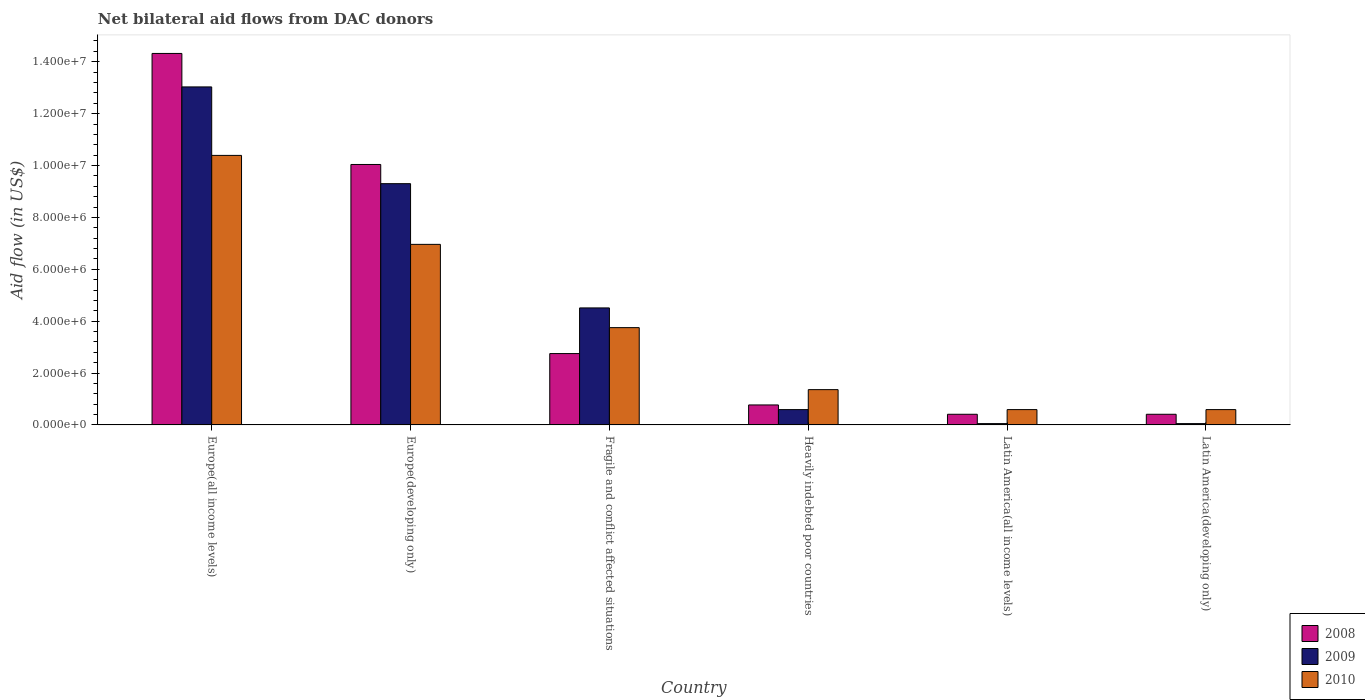How many different coloured bars are there?
Your answer should be compact. 3. How many groups of bars are there?
Give a very brief answer. 6. How many bars are there on the 2nd tick from the left?
Offer a very short reply. 3. How many bars are there on the 2nd tick from the right?
Offer a very short reply. 3. What is the label of the 1st group of bars from the left?
Provide a short and direct response. Europe(all income levels). In how many cases, is the number of bars for a given country not equal to the number of legend labels?
Provide a short and direct response. 0. What is the net bilateral aid flow in 2009 in Europe(all income levels)?
Offer a terse response. 1.30e+07. Across all countries, what is the maximum net bilateral aid flow in 2010?
Provide a short and direct response. 1.04e+07. In which country was the net bilateral aid flow in 2008 maximum?
Offer a very short reply. Europe(all income levels). In which country was the net bilateral aid flow in 2009 minimum?
Your answer should be compact. Latin America(all income levels). What is the total net bilateral aid flow in 2008 in the graph?
Offer a terse response. 2.87e+07. What is the difference between the net bilateral aid flow in 2010 in Heavily indebted poor countries and that in Latin America(all income levels)?
Your answer should be very brief. 7.70e+05. What is the difference between the net bilateral aid flow in 2010 in Latin America(all income levels) and the net bilateral aid flow in 2008 in Fragile and conflict affected situations?
Provide a short and direct response. -2.16e+06. What is the average net bilateral aid flow in 2009 per country?
Your answer should be very brief. 4.59e+06. What is the difference between the net bilateral aid flow of/in 2010 and net bilateral aid flow of/in 2009 in Europe(developing only)?
Offer a very short reply. -2.34e+06. What is the ratio of the net bilateral aid flow in 2008 in Europe(all income levels) to that in Europe(developing only)?
Provide a succinct answer. 1.43. Is the difference between the net bilateral aid flow in 2010 in Fragile and conflict affected situations and Latin America(all income levels) greater than the difference between the net bilateral aid flow in 2009 in Fragile and conflict affected situations and Latin America(all income levels)?
Give a very brief answer. No. What is the difference between the highest and the second highest net bilateral aid flow in 2009?
Keep it short and to the point. 3.73e+06. What is the difference between the highest and the lowest net bilateral aid flow in 2010?
Keep it short and to the point. 9.80e+06. In how many countries, is the net bilateral aid flow in 2008 greater than the average net bilateral aid flow in 2008 taken over all countries?
Give a very brief answer. 2. Is the sum of the net bilateral aid flow in 2008 in Europe(all income levels) and Latin America(all income levels) greater than the maximum net bilateral aid flow in 2009 across all countries?
Give a very brief answer. Yes. How many bars are there?
Provide a succinct answer. 18. How many countries are there in the graph?
Your answer should be very brief. 6. What is the difference between two consecutive major ticks on the Y-axis?
Offer a very short reply. 2.00e+06. Does the graph contain grids?
Offer a very short reply. No. How many legend labels are there?
Provide a short and direct response. 3. What is the title of the graph?
Give a very brief answer. Net bilateral aid flows from DAC donors. Does "2009" appear as one of the legend labels in the graph?
Give a very brief answer. Yes. What is the label or title of the Y-axis?
Offer a very short reply. Aid flow (in US$). What is the Aid flow (in US$) in 2008 in Europe(all income levels)?
Offer a very short reply. 1.43e+07. What is the Aid flow (in US$) of 2009 in Europe(all income levels)?
Keep it short and to the point. 1.30e+07. What is the Aid flow (in US$) of 2010 in Europe(all income levels)?
Offer a very short reply. 1.04e+07. What is the Aid flow (in US$) of 2008 in Europe(developing only)?
Ensure brevity in your answer.  1.00e+07. What is the Aid flow (in US$) in 2009 in Europe(developing only)?
Provide a short and direct response. 9.30e+06. What is the Aid flow (in US$) in 2010 in Europe(developing only)?
Provide a succinct answer. 6.96e+06. What is the Aid flow (in US$) of 2008 in Fragile and conflict affected situations?
Ensure brevity in your answer.  2.75e+06. What is the Aid flow (in US$) in 2009 in Fragile and conflict affected situations?
Your answer should be compact. 4.51e+06. What is the Aid flow (in US$) in 2010 in Fragile and conflict affected situations?
Your answer should be compact. 3.75e+06. What is the Aid flow (in US$) of 2008 in Heavily indebted poor countries?
Keep it short and to the point. 7.70e+05. What is the Aid flow (in US$) in 2009 in Heavily indebted poor countries?
Ensure brevity in your answer.  5.90e+05. What is the Aid flow (in US$) in 2010 in Heavily indebted poor countries?
Ensure brevity in your answer.  1.36e+06. What is the Aid flow (in US$) of 2010 in Latin America(all income levels)?
Ensure brevity in your answer.  5.90e+05. What is the Aid flow (in US$) of 2008 in Latin America(developing only)?
Ensure brevity in your answer.  4.10e+05. What is the Aid flow (in US$) in 2009 in Latin America(developing only)?
Provide a succinct answer. 5.00e+04. What is the Aid flow (in US$) in 2010 in Latin America(developing only)?
Provide a short and direct response. 5.90e+05. Across all countries, what is the maximum Aid flow (in US$) of 2008?
Your answer should be compact. 1.43e+07. Across all countries, what is the maximum Aid flow (in US$) of 2009?
Your answer should be compact. 1.30e+07. Across all countries, what is the maximum Aid flow (in US$) in 2010?
Provide a succinct answer. 1.04e+07. Across all countries, what is the minimum Aid flow (in US$) of 2008?
Your answer should be compact. 4.10e+05. Across all countries, what is the minimum Aid flow (in US$) in 2010?
Provide a succinct answer. 5.90e+05. What is the total Aid flow (in US$) in 2008 in the graph?
Offer a very short reply. 2.87e+07. What is the total Aid flow (in US$) of 2009 in the graph?
Provide a short and direct response. 2.75e+07. What is the total Aid flow (in US$) in 2010 in the graph?
Give a very brief answer. 2.36e+07. What is the difference between the Aid flow (in US$) in 2008 in Europe(all income levels) and that in Europe(developing only)?
Provide a succinct answer. 4.28e+06. What is the difference between the Aid flow (in US$) of 2009 in Europe(all income levels) and that in Europe(developing only)?
Your answer should be very brief. 3.73e+06. What is the difference between the Aid flow (in US$) of 2010 in Europe(all income levels) and that in Europe(developing only)?
Provide a short and direct response. 3.43e+06. What is the difference between the Aid flow (in US$) of 2008 in Europe(all income levels) and that in Fragile and conflict affected situations?
Your response must be concise. 1.16e+07. What is the difference between the Aid flow (in US$) in 2009 in Europe(all income levels) and that in Fragile and conflict affected situations?
Provide a succinct answer. 8.52e+06. What is the difference between the Aid flow (in US$) in 2010 in Europe(all income levels) and that in Fragile and conflict affected situations?
Give a very brief answer. 6.64e+06. What is the difference between the Aid flow (in US$) of 2008 in Europe(all income levels) and that in Heavily indebted poor countries?
Make the answer very short. 1.36e+07. What is the difference between the Aid flow (in US$) in 2009 in Europe(all income levels) and that in Heavily indebted poor countries?
Make the answer very short. 1.24e+07. What is the difference between the Aid flow (in US$) in 2010 in Europe(all income levels) and that in Heavily indebted poor countries?
Keep it short and to the point. 9.03e+06. What is the difference between the Aid flow (in US$) in 2008 in Europe(all income levels) and that in Latin America(all income levels)?
Your answer should be very brief. 1.39e+07. What is the difference between the Aid flow (in US$) of 2009 in Europe(all income levels) and that in Latin America(all income levels)?
Make the answer very short. 1.30e+07. What is the difference between the Aid flow (in US$) in 2010 in Europe(all income levels) and that in Latin America(all income levels)?
Your answer should be compact. 9.80e+06. What is the difference between the Aid flow (in US$) of 2008 in Europe(all income levels) and that in Latin America(developing only)?
Provide a short and direct response. 1.39e+07. What is the difference between the Aid flow (in US$) in 2009 in Europe(all income levels) and that in Latin America(developing only)?
Ensure brevity in your answer.  1.30e+07. What is the difference between the Aid flow (in US$) of 2010 in Europe(all income levels) and that in Latin America(developing only)?
Provide a succinct answer. 9.80e+06. What is the difference between the Aid flow (in US$) in 2008 in Europe(developing only) and that in Fragile and conflict affected situations?
Your response must be concise. 7.29e+06. What is the difference between the Aid flow (in US$) in 2009 in Europe(developing only) and that in Fragile and conflict affected situations?
Offer a very short reply. 4.79e+06. What is the difference between the Aid flow (in US$) in 2010 in Europe(developing only) and that in Fragile and conflict affected situations?
Offer a very short reply. 3.21e+06. What is the difference between the Aid flow (in US$) of 2008 in Europe(developing only) and that in Heavily indebted poor countries?
Ensure brevity in your answer.  9.27e+06. What is the difference between the Aid flow (in US$) in 2009 in Europe(developing only) and that in Heavily indebted poor countries?
Keep it short and to the point. 8.71e+06. What is the difference between the Aid flow (in US$) in 2010 in Europe(developing only) and that in Heavily indebted poor countries?
Give a very brief answer. 5.60e+06. What is the difference between the Aid flow (in US$) of 2008 in Europe(developing only) and that in Latin America(all income levels)?
Give a very brief answer. 9.63e+06. What is the difference between the Aid flow (in US$) in 2009 in Europe(developing only) and that in Latin America(all income levels)?
Your answer should be very brief. 9.25e+06. What is the difference between the Aid flow (in US$) of 2010 in Europe(developing only) and that in Latin America(all income levels)?
Give a very brief answer. 6.37e+06. What is the difference between the Aid flow (in US$) of 2008 in Europe(developing only) and that in Latin America(developing only)?
Your answer should be compact. 9.63e+06. What is the difference between the Aid flow (in US$) in 2009 in Europe(developing only) and that in Latin America(developing only)?
Make the answer very short. 9.25e+06. What is the difference between the Aid flow (in US$) in 2010 in Europe(developing only) and that in Latin America(developing only)?
Ensure brevity in your answer.  6.37e+06. What is the difference between the Aid flow (in US$) of 2008 in Fragile and conflict affected situations and that in Heavily indebted poor countries?
Your answer should be compact. 1.98e+06. What is the difference between the Aid flow (in US$) in 2009 in Fragile and conflict affected situations and that in Heavily indebted poor countries?
Provide a succinct answer. 3.92e+06. What is the difference between the Aid flow (in US$) in 2010 in Fragile and conflict affected situations and that in Heavily indebted poor countries?
Offer a terse response. 2.39e+06. What is the difference between the Aid flow (in US$) of 2008 in Fragile and conflict affected situations and that in Latin America(all income levels)?
Offer a very short reply. 2.34e+06. What is the difference between the Aid flow (in US$) of 2009 in Fragile and conflict affected situations and that in Latin America(all income levels)?
Give a very brief answer. 4.46e+06. What is the difference between the Aid flow (in US$) of 2010 in Fragile and conflict affected situations and that in Latin America(all income levels)?
Your answer should be compact. 3.16e+06. What is the difference between the Aid flow (in US$) of 2008 in Fragile and conflict affected situations and that in Latin America(developing only)?
Offer a very short reply. 2.34e+06. What is the difference between the Aid flow (in US$) in 2009 in Fragile and conflict affected situations and that in Latin America(developing only)?
Keep it short and to the point. 4.46e+06. What is the difference between the Aid flow (in US$) of 2010 in Fragile and conflict affected situations and that in Latin America(developing only)?
Your answer should be very brief. 3.16e+06. What is the difference between the Aid flow (in US$) in 2009 in Heavily indebted poor countries and that in Latin America(all income levels)?
Your response must be concise. 5.40e+05. What is the difference between the Aid flow (in US$) in 2010 in Heavily indebted poor countries and that in Latin America(all income levels)?
Provide a short and direct response. 7.70e+05. What is the difference between the Aid flow (in US$) of 2008 in Heavily indebted poor countries and that in Latin America(developing only)?
Offer a very short reply. 3.60e+05. What is the difference between the Aid flow (in US$) in 2009 in Heavily indebted poor countries and that in Latin America(developing only)?
Your response must be concise. 5.40e+05. What is the difference between the Aid flow (in US$) in 2010 in Heavily indebted poor countries and that in Latin America(developing only)?
Your response must be concise. 7.70e+05. What is the difference between the Aid flow (in US$) in 2010 in Latin America(all income levels) and that in Latin America(developing only)?
Provide a short and direct response. 0. What is the difference between the Aid flow (in US$) of 2008 in Europe(all income levels) and the Aid flow (in US$) of 2009 in Europe(developing only)?
Your answer should be very brief. 5.02e+06. What is the difference between the Aid flow (in US$) in 2008 in Europe(all income levels) and the Aid flow (in US$) in 2010 in Europe(developing only)?
Ensure brevity in your answer.  7.36e+06. What is the difference between the Aid flow (in US$) in 2009 in Europe(all income levels) and the Aid flow (in US$) in 2010 in Europe(developing only)?
Provide a short and direct response. 6.07e+06. What is the difference between the Aid flow (in US$) of 2008 in Europe(all income levels) and the Aid flow (in US$) of 2009 in Fragile and conflict affected situations?
Provide a succinct answer. 9.81e+06. What is the difference between the Aid flow (in US$) in 2008 in Europe(all income levels) and the Aid flow (in US$) in 2010 in Fragile and conflict affected situations?
Provide a succinct answer. 1.06e+07. What is the difference between the Aid flow (in US$) in 2009 in Europe(all income levels) and the Aid flow (in US$) in 2010 in Fragile and conflict affected situations?
Keep it short and to the point. 9.28e+06. What is the difference between the Aid flow (in US$) in 2008 in Europe(all income levels) and the Aid flow (in US$) in 2009 in Heavily indebted poor countries?
Provide a succinct answer. 1.37e+07. What is the difference between the Aid flow (in US$) in 2008 in Europe(all income levels) and the Aid flow (in US$) in 2010 in Heavily indebted poor countries?
Provide a short and direct response. 1.30e+07. What is the difference between the Aid flow (in US$) in 2009 in Europe(all income levels) and the Aid flow (in US$) in 2010 in Heavily indebted poor countries?
Provide a succinct answer. 1.17e+07. What is the difference between the Aid flow (in US$) in 2008 in Europe(all income levels) and the Aid flow (in US$) in 2009 in Latin America(all income levels)?
Your answer should be compact. 1.43e+07. What is the difference between the Aid flow (in US$) in 2008 in Europe(all income levels) and the Aid flow (in US$) in 2010 in Latin America(all income levels)?
Your answer should be very brief. 1.37e+07. What is the difference between the Aid flow (in US$) in 2009 in Europe(all income levels) and the Aid flow (in US$) in 2010 in Latin America(all income levels)?
Offer a terse response. 1.24e+07. What is the difference between the Aid flow (in US$) in 2008 in Europe(all income levels) and the Aid flow (in US$) in 2009 in Latin America(developing only)?
Ensure brevity in your answer.  1.43e+07. What is the difference between the Aid flow (in US$) in 2008 in Europe(all income levels) and the Aid flow (in US$) in 2010 in Latin America(developing only)?
Your answer should be very brief. 1.37e+07. What is the difference between the Aid flow (in US$) of 2009 in Europe(all income levels) and the Aid flow (in US$) of 2010 in Latin America(developing only)?
Your answer should be compact. 1.24e+07. What is the difference between the Aid flow (in US$) in 2008 in Europe(developing only) and the Aid flow (in US$) in 2009 in Fragile and conflict affected situations?
Your answer should be compact. 5.53e+06. What is the difference between the Aid flow (in US$) of 2008 in Europe(developing only) and the Aid flow (in US$) of 2010 in Fragile and conflict affected situations?
Your response must be concise. 6.29e+06. What is the difference between the Aid flow (in US$) of 2009 in Europe(developing only) and the Aid flow (in US$) of 2010 in Fragile and conflict affected situations?
Your answer should be compact. 5.55e+06. What is the difference between the Aid flow (in US$) of 2008 in Europe(developing only) and the Aid flow (in US$) of 2009 in Heavily indebted poor countries?
Provide a succinct answer. 9.45e+06. What is the difference between the Aid flow (in US$) of 2008 in Europe(developing only) and the Aid flow (in US$) of 2010 in Heavily indebted poor countries?
Make the answer very short. 8.68e+06. What is the difference between the Aid flow (in US$) of 2009 in Europe(developing only) and the Aid flow (in US$) of 2010 in Heavily indebted poor countries?
Offer a terse response. 7.94e+06. What is the difference between the Aid flow (in US$) of 2008 in Europe(developing only) and the Aid flow (in US$) of 2009 in Latin America(all income levels)?
Offer a very short reply. 9.99e+06. What is the difference between the Aid flow (in US$) in 2008 in Europe(developing only) and the Aid flow (in US$) in 2010 in Latin America(all income levels)?
Provide a short and direct response. 9.45e+06. What is the difference between the Aid flow (in US$) of 2009 in Europe(developing only) and the Aid flow (in US$) of 2010 in Latin America(all income levels)?
Provide a succinct answer. 8.71e+06. What is the difference between the Aid flow (in US$) in 2008 in Europe(developing only) and the Aid flow (in US$) in 2009 in Latin America(developing only)?
Your answer should be compact. 9.99e+06. What is the difference between the Aid flow (in US$) in 2008 in Europe(developing only) and the Aid flow (in US$) in 2010 in Latin America(developing only)?
Give a very brief answer. 9.45e+06. What is the difference between the Aid flow (in US$) of 2009 in Europe(developing only) and the Aid flow (in US$) of 2010 in Latin America(developing only)?
Your answer should be compact. 8.71e+06. What is the difference between the Aid flow (in US$) of 2008 in Fragile and conflict affected situations and the Aid flow (in US$) of 2009 in Heavily indebted poor countries?
Your answer should be compact. 2.16e+06. What is the difference between the Aid flow (in US$) in 2008 in Fragile and conflict affected situations and the Aid flow (in US$) in 2010 in Heavily indebted poor countries?
Make the answer very short. 1.39e+06. What is the difference between the Aid flow (in US$) in 2009 in Fragile and conflict affected situations and the Aid flow (in US$) in 2010 in Heavily indebted poor countries?
Give a very brief answer. 3.15e+06. What is the difference between the Aid flow (in US$) of 2008 in Fragile and conflict affected situations and the Aid flow (in US$) of 2009 in Latin America(all income levels)?
Provide a succinct answer. 2.70e+06. What is the difference between the Aid flow (in US$) in 2008 in Fragile and conflict affected situations and the Aid flow (in US$) in 2010 in Latin America(all income levels)?
Your answer should be compact. 2.16e+06. What is the difference between the Aid flow (in US$) of 2009 in Fragile and conflict affected situations and the Aid flow (in US$) of 2010 in Latin America(all income levels)?
Offer a very short reply. 3.92e+06. What is the difference between the Aid flow (in US$) of 2008 in Fragile and conflict affected situations and the Aid flow (in US$) of 2009 in Latin America(developing only)?
Give a very brief answer. 2.70e+06. What is the difference between the Aid flow (in US$) in 2008 in Fragile and conflict affected situations and the Aid flow (in US$) in 2010 in Latin America(developing only)?
Your response must be concise. 2.16e+06. What is the difference between the Aid flow (in US$) in 2009 in Fragile and conflict affected situations and the Aid flow (in US$) in 2010 in Latin America(developing only)?
Your answer should be very brief. 3.92e+06. What is the difference between the Aid flow (in US$) of 2008 in Heavily indebted poor countries and the Aid flow (in US$) of 2009 in Latin America(all income levels)?
Ensure brevity in your answer.  7.20e+05. What is the difference between the Aid flow (in US$) in 2008 in Heavily indebted poor countries and the Aid flow (in US$) in 2010 in Latin America(all income levels)?
Offer a terse response. 1.80e+05. What is the difference between the Aid flow (in US$) of 2008 in Heavily indebted poor countries and the Aid flow (in US$) of 2009 in Latin America(developing only)?
Make the answer very short. 7.20e+05. What is the difference between the Aid flow (in US$) in 2008 in Heavily indebted poor countries and the Aid flow (in US$) in 2010 in Latin America(developing only)?
Your response must be concise. 1.80e+05. What is the difference between the Aid flow (in US$) of 2008 in Latin America(all income levels) and the Aid flow (in US$) of 2010 in Latin America(developing only)?
Ensure brevity in your answer.  -1.80e+05. What is the difference between the Aid flow (in US$) in 2009 in Latin America(all income levels) and the Aid flow (in US$) in 2010 in Latin America(developing only)?
Your response must be concise. -5.40e+05. What is the average Aid flow (in US$) in 2008 per country?
Offer a very short reply. 4.78e+06. What is the average Aid flow (in US$) in 2009 per country?
Your answer should be very brief. 4.59e+06. What is the average Aid flow (in US$) of 2010 per country?
Offer a very short reply. 3.94e+06. What is the difference between the Aid flow (in US$) of 2008 and Aid flow (in US$) of 2009 in Europe(all income levels)?
Provide a succinct answer. 1.29e+06. What is the difference between the Aid flow (in US$) of 2008 and Aid flow (in US$) of 2010 in Europe(all income levels)?
Make the answer very short. 3.93e+06. What is the difference between the Aid flow (in US$) in 2009 and Aid flow (in US$) in 2010 in Europe(all income levels)?
Provide a succinct answer. 2.64e+06. What is the difference between the Aid flow (in US$) of 2008 and Aid flow (in US$) of 2009 in Europe(developing only)?
Make the answer very short. 7.40e+05. What is the difference between the Aid flow (in US$) in 2008 and Aid flow (in US$) in 2010 in Europe(developing only)?
Offer a terse response. 3.08e+06. What is the difference between the Aid flow (in US$) of 2009 and Aid flow (in US$) of 2010 in Europe(developing only)?
Your response must be concise. 2.34e+06. What is the difference between the Aid flow (in US$) of 2008 and Aid flow (in US$) of 2009 in Fragile and conflict affected situations?
Your response must be concise. -1.76e+06. What is the difference between the Aid flow (in US$) in 2009 and Aid flow (in US$) in 2010 in Fragile and conflict affected situations?
Make the answer very short. 7.60e+05. What is the difference between the Aid flow (in US$) of 2008 and Aid flow (in US$) of 2010 in Heavily indebted poor countries?
Offer a very short reply. -5.90e+05. What is the difference between the Aid flow (in US$) in 2009 and Aid flow (in US$) in 2010 in Heavily indebted poor countries?
Your answer should be compact. -7.70e+05. What is the difference between the Aid flow (in US$) in 2008 and Aid flow (in US$) in 2009 in Latin America(all income levels)?
Ensure brevity in your answer.  3.60e+05. What is the difference between the Aid flow (in US$) of 2009 and Aid flow (in US$) of 2010 in Latin America(all income levels)?
Provide a short and direct response. -5.40e+05. What is the difference between the Aid flow (in US$) of 2008 and Aid flow (in US$) of 2010 in Latin America(developing only)?
Offer a terse response. -1.80e+05. What is the difference between the Aid flow (in US$) of 2009 and Aid flow (in US$) of 2010 in Latin America(developing only)?
Offer a very short reply. -5.40e+05. What is the ratio of the Aid flow (in US$) in 2008 in Europe(all income levels) to that in Europe(developing only)?
Give a very brief answer. 1.43. What is the ratio of the Aid flow (in US$) of 2009 in Europe(all income levels) to that in Europe(developing only)?
Your answer should be compact. 1.4. What is the ratio of the Aid flow (in US$) in 2010 in Europe(all income levels) to that in Europe(developing only)?
Your response must be concise. 1.49. What is the ratio of the Aid flow (in US$) in 2008 in Europe(all income levels) to that in Fragile and conflict affected situations?
Provide a short and direct response. 5.21. What is the ratio of the Aid flow (in US$) in 2009 in Europe(all income levels) to that in Fragile and conflict affected situations?
Ensure brevity in your answer.  2.89. What is the ratio of the Aid flow (in US$) in 2010 in Europe(all income levels) to that in Fragile and conflict affected situations?
Keep it short and to the point. 2.77. What is the ratio of the Aid flow (in US$) of 2008 in Europe(all income levels) to that in Heavily indebted poor countries?
Provide a succinct answer. 18.6. What is the ratio of the Aid flow (in US$) of 2009 in Europe(all income levels) to that in Heavily indebted poor countries?
Your answer should be compact. 22.08. What is the ratio of the Aid flow (in US$) of 2010 in Europe(all income levels) to that in Heavily indebted poor countries?
Give a very brief answer. 7.64. What is the ratio of the Aid flow (in US$) in 2008 in Europe(all income levels) to that in Latin America(all income levels)?
Your answer should be compact. 34.93. What is the ratio of the Aid flow (in US$) of 2009 in Europe(all income levels) to that in Latin America(all income levels)?
Give a very brief answer. 260.6. What is the ratio of the Aid flow (in US$) in 2010 in Europe(all income levels) to that in Latin America(all income levels)?
Give a very brief answer. 17.61. What is the ratio of the Aid flow (in US$) of 2008 in Europe(all income levels) to that in Latin America(developing only)?
Give a very brief answer. 34.93. What is the ratio of the Aid flow (in US$) of 2009 in Europe(all income levels) to that in Latin America(developing only)?
Provide a short and direct response. 260.6. What is the ratio of the Aid flow (in US$) in 2010 in Europe(all income levels) to that in Latin America(developing only)?
Your answer should be very brief. 17.61. What is the ratio of the Aid flow (in US$) of 2008 in Europe(developing only) to that in Fragile and conflict affected situations?
Your response must be concise. 3.65. What is the ratio of the Aid flow (in US$) of 2009 in Europe(developing only) to that in Fragile and conflict affected situations?
Your answer should be very brief. 2.06. What is the ratio of the Aid flow (in US$) of 2010 in Europe(developing only) to that in Fragile and conflict affected situations?
Your response must be concise. 1.86. What is the ratio of the Aid flow (in US$) in 2008 in Europe(developing only) to that in Heavily indebted poor countries?
Offer a very short reply. 13.04. What is the ratio of the Aid flow (in US$) of 2009 in Europe(developing only) to that in Heavily indebted poor countries?
Give a very brief answer. 15.76. What is the ratio of the Aid flow (in US$) of 2010 in Europe(developing only) to that in Heavily indebted poor countries?
Provide a short and direct response. 5.12. What is the ratio of the Aid flow (in US$) of 2008 in Europe(developing only) to that in Latin America(all income levels)?
Offer a terse response. 24.49. What is the ratio of the Aid flow (in US$) in 2009 in Europe(developing only) to that in Latin America(all income levels)?
Offer a very short reply. 186. What is the ratio of the Aid flow (in US$) in 2010 in Europe(developing only) to that in Latin America(all income levels)?
Give a very brief answer. 11.8. What is the ratio of the Aid flow (in US$) in 2008 in Europe(developing only) to that in Latin America(developing only)?
Provide a succinct answer. 24.49. What is the ratio of the Aid flow (in US$) of 2009 in Europe(developing only) to that in Latin America(developing only)?
Offer a terse response. 186. What is the ratio of the Aid flow (in US$) in 2010 in Europe(developing only) to that in Latin America(developing only)?
Provide a succinct answer. 11.8. What is the ratio of the Aid flow (in US$) in 2008 in Fragile and conflict affected situations to that in Heavily indebted poor countries?
Offer a very short reply. 3.57. What is the ratio of the Aid flow (in US$) in 2009 in Fragile and conflict affected situations to that in Heavily indebted poor countries?
Keep it short and to the point. 7.64. What is the ratio of the Aid flow (in US$) of 2010 in Fragile and conflict affected situations to that in Heavily indebted poor countries?
Give a very brief answer. 2.76. What is the ratio of the Aid flow (in US$) in 2008 in Fragile and conflict affected situations to that in Latin America(all income levels)?
Your response must be concise. 6.71. What is the ratio of the Aid flow (in US$) in 2009 in Fragile and conflict affected situations to that in Latin America(all income levels)?
Your answer should be very brief. 90.2. What is the ratio of the Aid flow (in US$) of 2010 in Fragile and conflict affected situations to that in Latin America(all income levels)?
Offer a terse response. 6.36. What is the ratio of the Aid flow (in US$) of 2008 in Fragile and conflict affected situations to that in Latin America(developing only)?
Ensure brevity in your answer.  6.71. What is the ratio of the Aid flow (in US$) of 2009 in Fragile and conflict affected situations to that in Latin America(developing only)?
Provide a short and direct response. 90.2. What is the ratio of the Aid flow (in US$) of 2010 in Fragile and conflict affected situations to that in Latin America(developing only)?
Provide a short and direct response. 6.36. What is the ratio of the Aid flow (in US$) of 2008 in Heavily indebted poor countries to that in Latin America(all income levels)?
Your answer should be compact. 1.88. What is the ratio of the Aid flow (in US$) of 2010 in Heavily indebted poor countries to that in Latin America(all income levels)?
Your answer should be very brief. 2.31. What is the ratio of the Aid flow (in US$) in 2008 in Heavily indebted poor countries to that in Latin America(developing only)?
Give a very brief answer. 1.88. What is the ratio of the Aid flow (in US$) of 2009 in Heavily indebted poor countries to that in Latin America(developing only)?
Ensure brevity in your answer.  11.8. What is the ratio of the Aid flow (in US$) in 2010 in Heavily indebted poor countries to that in Latin America(developing only)?
Provide a succinct answer. 2.31. What is the ratio of the Aid flow (in US$) in 2010 in Latin America(all income levels) to that in Latin America(developing only)?
Keep it short and to the point. 1. What is the difference between the highest and the second highest Aid flow (in US$) of 2008?
Offer a terse response. 4.28e+06. What is the difference between the highest and the second highest Aid flow (in US$) in 2009?
Your answer should be compact. 3.73e+06. What is the difference between the highest and the second highest Aid flow (in US$) in 2010?
Your answer should be very brief. 3.43e+06. What is the difference between the highest and the lowest Aid flow (in US$) of 2008?
Give a very brief answer. 1.39e+07. What is the difference between the highest and the lowest Aid flow (in US$) of 2009?
Give a very brief answer. 1.30e+07. What is the difference between the highest and the lowest Aid flow (in US$) of 2010?
Offer a very short reply. 9.80e+06. 